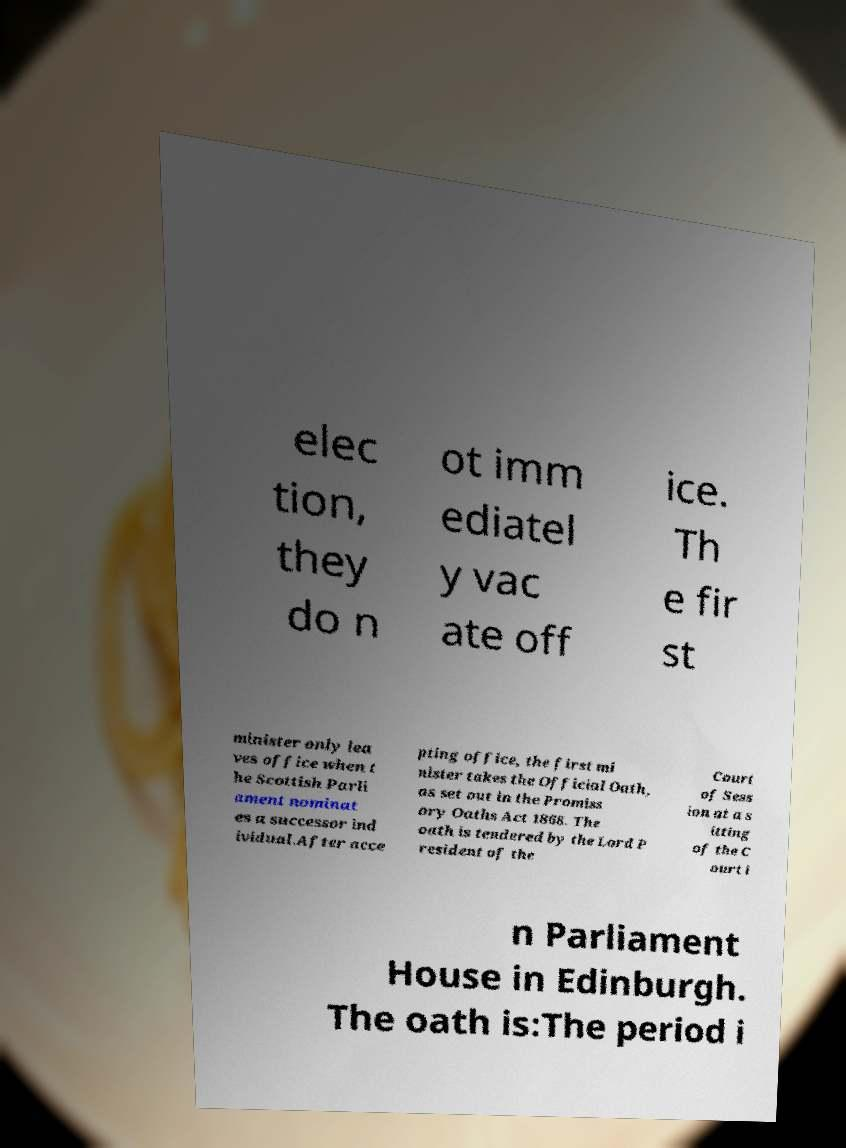What messages or text are displayed in this image? I need them in a readable, typed format. elec tion, they do n ot imm ediatel y vac ate off ice. Th e fir st minister only lea ves office when t he Scottish Parli ament nominat es a successor ind ividual.After acce pting office, the first mi nister takes the Official Oath, as set out in the Promiss ory Oaths Act 1868. The oath is tendered by the Lord P resident of the Court of Sess ion at a s itting of the C ourt i n Parliament House in Edinburgh. The oath is:The period i 